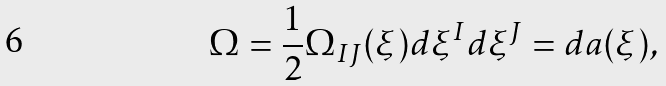<formula> <loc_0><loc_0><loc_500><loc_500>\Omega = \frac { 1 } { 2 } \Omega _ { I J } ( \xi ) d \xi ^ { I } d \xi ^ { J } = d a ( \xi ) ,</formula> 